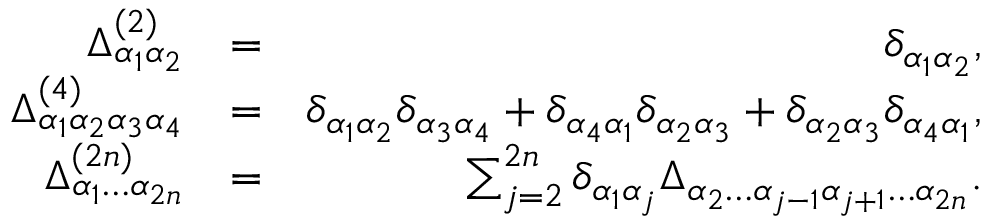<formula> <loc_0><loc_0><loc_500><loc_500>\begin{array} { r l r } { \Delta _ { \alpha _ { 1 } \alpha _ { 2 } } ^ { ( 2 ) } } & { = } & { \delta _ { \alpha _ { 1 } \alpha _ { 2 } } , } \\ { \Delta _ { \alpha _ { 1 } \alpha _ { 2 } \alpha _ { 3 } \alpha _ { 4 } } ^ { ( 4 ) } } & { = } & { \delta _ { \alpha _ { 1 } \alpha _ { 2 } } \delta _ { \alpha _ { 3 } \alpha _ { 4 } } + \delta _ { \alpha _ { 4 } \alpha _ { 1 } } \delta _ { \alpha _ { 2 } \alpha _ { 3 } } + \delta _ { \alpha _ { 2 } \alpha _ { 3 } } \delta _ { \alpha _ { 4 } \alpha _ { 1 } } , } \\ { \Delta _ { \alpha _ { 1 } \dots \alpha _ { 2 n } } ^ { ( 2 n ) } } & { = } & { \sum _ { j = 2 } ^ { 2 n } \delta _ { \alpha _ { 1 } \alpha _ { j } } \Delta _ { \alpha _ { 2 } \dots \alpha _ { j - 1 } \alpha _ { j + 1 } \dots \alpha _ { 2 n } } . } \end{array}</formula> 